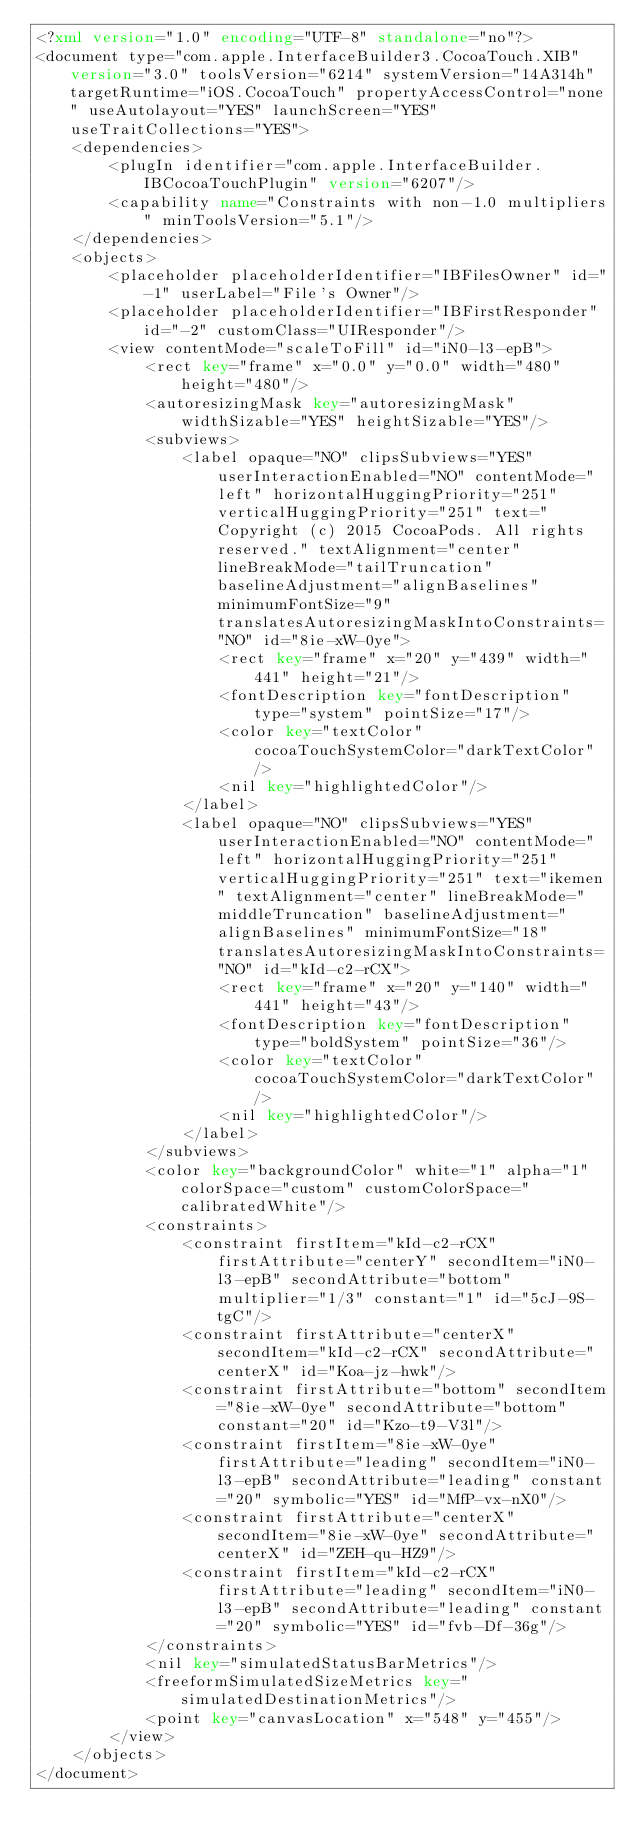<code> <loc_0><loc_0><loc_500><loc_500><_XML_><?xml version="1.0" encoding="UTF-8" standalone="no"?>
<document type="com.apple.InterfaceBuilder3.CocoaTouch.XIB" version="3.0" toolsVersion="6214" systemVersion="14A314h" targetRuntime="iOS.CocoaTouch" propertyAccessControl="none" useAutolayout="YES" launchScreen="YES" useTraitCollections="YES">
    <dependencies>
        <plugIn identifier="com.apple.InterfaceBuilder.IBCocoaTouchPlugin" version="6207"/>
        <capability name="Constraints with non-1.0 multipliers" minToolsVersion="5.1"/>
    </dependencies>
    <objects>
        <placeholder placeholderIdentifier="IBFilesOwner" id="-1" userLabel="File's Owner"/>
        <placeholder placeholderIdentifier="IBFirstResponder" id="-2" customClass="UIResponder"/>
        <view contentMode="scaleToFill" id="iN0-l3-epB">
            <rect key="frame" x="0.0" y="0.0" width="480" height="480"/>
            <autoresizingMask key="autoresizingMask" widthSizable="YES" heightSizable="YES"/>
            <subviews>
                <label opaque="NO" clipsSubviews="YES" userInteractionEnabled="NO" contentMode="left" horizontalHuggingPriority="251" verticalHuggingPriority="251" text="  Copyright (c) 2015 CocoaPods. All rights reserved." textAlignment="center" lineBreakMode="tailTruncation" baselineAdjustment="alignBaselines" minimumFontSize="9" translatesAutoresizingMaskIntoConstraints="NO" id="8ie-xW-0ye">
                    <rect key="frame" x="20" y="439" width="441" height="21"/>
                    <fontDescription key="fontDescription" type="system" pointSize="17"/>
                    <color key="textColor" cocoaTouchSystemColor="darkTextColor"/>
                    <nil key="highlightedColor"/>
                </label>
                <label opaque="NO" clipsSubviews="YES" userInteractionEnabled="NO" contentMode="left" horizontalHuggingPriority="251" verticalHuggingPriority="251" text="ikemen" textAlignment="center" lineBreakMode="middleTruncation" baselineAdjustment="alignBaselines" minimumFontSize="18" translatesAutoresizingMaskIntoConstraints="NO" id="kId-c2-rCX">
                    <rect key="frame" x="20" y="140" width="441" height="43"/>
                    <fontDescription key="fontDescription" type="boldSystem" pointSize="36"/>
                    <color key="textColor" cocoaTouchSystemColor="darkTextColor"/>
                    <nil key="highlightedColor"/>
                </label>
            </subviews>
            <color key="backgroundColor" white="1" alpha="1" colorSpace="custom" customColorSpace="calibratedWhite"/>
            <constraints>
                <constraint firstItem="kId-c2-rCX" firstAttribute="centerY" secondItem="iN0-l3-epB" secondAttribute="bottom" multiplier="1/3" constant="1" id="5cJ-9S-tgC"/>
                <constraint firstAttribute="centerX" secondItem="kId-c2-rCX" secondAttribute="centerX" id="Koa-jz-hwk"/>
                <constraint firstAttribute="bottom" secondItem="8ie-xW-0ye" secondAttribute="bottom" constant="20" id="Kzo-t9-V3l"/>
                <constraint firstItem="8ie-xW-0ye" firstAttribute="leading" secondItem="iN0-l3-epB" secondAttribute="leading" constant="20" symbolic="YES" id="MfP-vx-nX0"/>
                <constraint firstAttribute="centerX" secondItem="8ie-xW-0ye" secondAttribute="centerX" id="ZEH-qu-HZ9"/>
                <constraint firstItem="kId-c2-rCX" firstAttribute="leading" secondItem="iN0-l3-epB" secondAttribute="leading" constant="20" symbolic="YES" id="fvb-Df-36g"/>
            </constraints>
            <nil key="simulatedStatusBarMetrics"/>
            <freeformSimulatedSizeMetrics key="simulatedDestinationMetrics"/>
            <point key="canvasLocation" x="548" y="455"/>
        </view>
    </objects>
</document>
</code> 